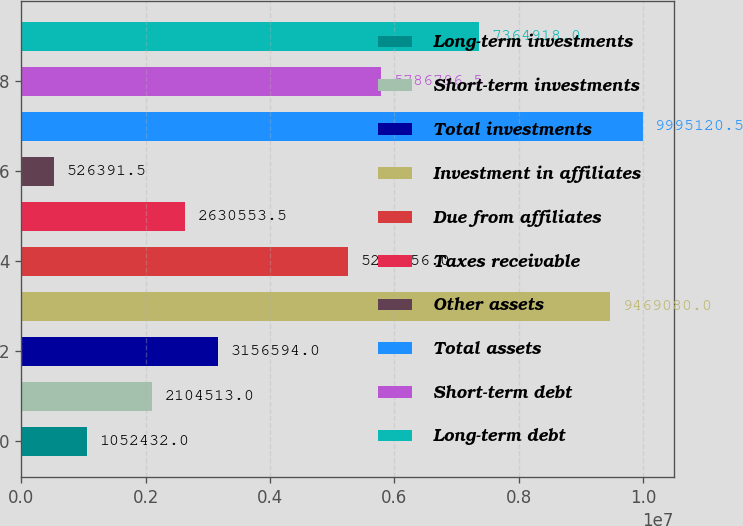Convert chart. <chart><loc_0><loc_0><loc_500><loc_500><bar_chart><fcel>Long-term investments<fcel>Short-term investments<fcel>Total investments<fcel>Investment in affiliates<fcel>Due from affiliates<fcel>Taxes receivable<fcel>Other assets<fcel>Total assets<fcel>Short-term debt<fcel>Long-term debt<nl><fcel>1.05243e+06<fcel>2.10451e+06<fcel>3.15659e+06<fcel>9.46908e+06<fcel>5.26076e+06<fcel>2.63055e+06<fcel>526392<fcel>9.99512e+06<fcel>5.7868e+06<fcel>7.36492e+06<nl></chart> 